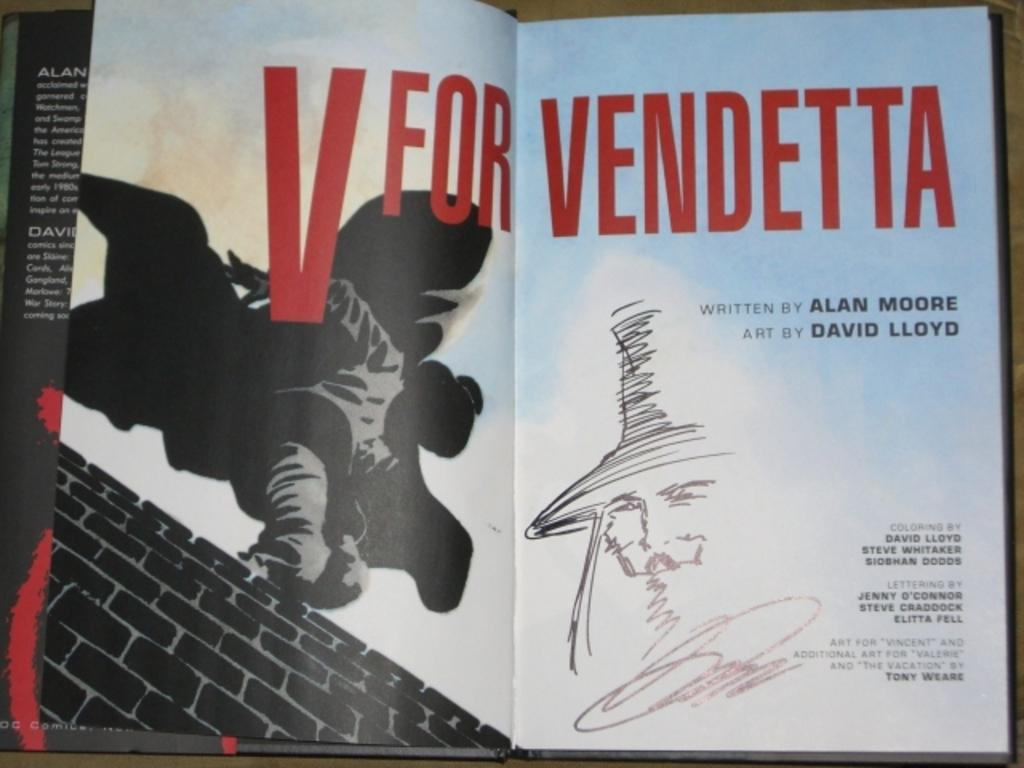<image>
Summarize the visual content of the image. A book that is open showing V for Vendetta on two pages. 